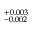Convert formula to latex. <formula><loc_0><loc_0><loc_500><loc_500>^ { + 0 . 0 0 3 } _ { - 0 . 0 0 2 }</formula> 